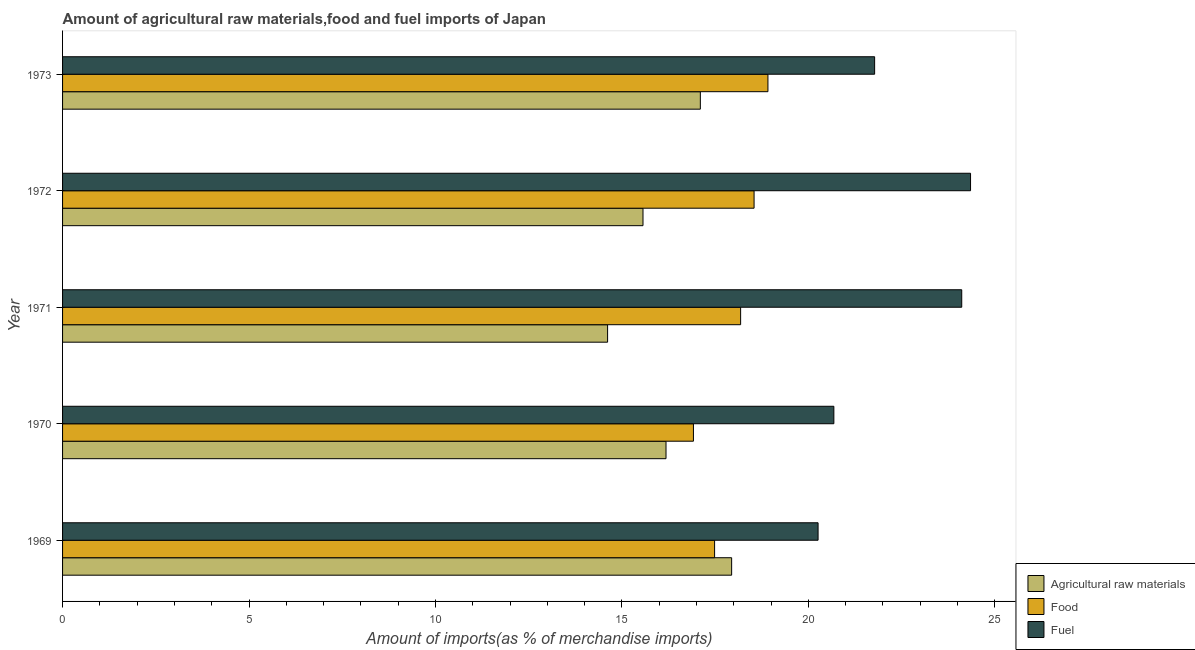How many groups of bars are there?
Make the answer very short. 5. Are the number of bars per tick equal to the number of legend labels?
Your answer should be compact. Yes. How many bars are there on the 5th tick from the top?
Your answer should be compact. 3. What is the label of the 2nd group of bars from the top?
Your answer should be very brief. 1972. What is the percentage of raw materials imports in 1972?
Your answer should be very brief. 15.57. Across all years, what is the maximum percentage of fuel imports?
Your answer should be very brief. 24.35. Across all years, what is the minimum percentage of fuel imports?
Provide a succinct answer. 20.26. In which year was the percentage of raw materials imports maximum?
Give a very brief answer. 1969. In which year was the percentage of raw materials imports minimum?
Make the answer very short. 1971. What is the total percentage of food imports in the graph?
Make the answer very short. 90.05. What is the difference between the percentage of fuel imports in 1969 and that in 1970?
Make the answer very short. -0.42. What is the difference between the percentage of raw materials imports in 1969 and the percentage of fuel imports in 1972?
Provide a short and direct response. -6.41. What is the average percentage of food imports per year?
Your response must be concise. 18.01. In the year 1973, what is the difference between the percentage of food imports and percentage of raw materials imports?
Your answer should be very brief. 1.81. What is the ratio of the percentage of fuel imports in 1971 to that in 1972?
Offer a very short reply. 0.99. Is the percentage of fuel imports in 1969 less than that in 1970?
Provide a succinct answer. Yes. Is the difference between the percentage of food imports in 1971 and 1972 greater than the difference between the percentage of raw materials imports in 1971 and 1972?
Ensure brevity in your answer.  Yes. What is the difference between the highest and the second highest percentage of food imports?
Give a very brief answer. 0.37. What is the difference between the highest and the lowest percentage of fuel imports?
Offer a terse response. 4.09. In how many years, is the percentage of fuel imports greater than the average percentage of fuel imports taken over all years?
Provide a short and direct response. 2. What does the 3rd bar from the top in 1972 represents?
Your response must be concise. Agricultural raw materials. What does the 1st bar from the bottom in 1969 represents?
Offer a very short reply. Agricultural raw materials. How many bars are there?
Your response must be concise. 15. Are the values on the major ticks of X-axis written in scientific E-notation?
Make the answer very short. No. Does the graph contain any zero values?
Keep it short and to the point. No. Does the graph contain grids?
Keep it short and to the point. No. How many legend labels are there?
Provide a short and direct response. 3. How are the legend labels stacked?
Your response must be concise. Vertical. What is the title of the graph?
Ensure brevity in your answer.  Amount of agricultural raw materials,food and fuel imports of Japan. What is the label or title of the X-axis?
Offer a terse response. Amount of imports(as % of merchandise imports). What is the Amount of imports(as % of merchandise imports) in Agricultural raw materials in 1969?
Provide a short and direct response. 17.94. What is the Amount of imports(as % of merchandise imports) of Food in 1969?
Give a very brief answer. 17.49. What is the Amount of imports(as % of merchandise imports) in Fuel in 1969?
Provide a succinct answer. 20.26. What is the Amount of imports(as % of merchandise imports) in Agricultural raw materials in 1970?
Provide a short and direct response. 16.18. What is the Amount of imports(as % of merchandise imports) in Food in 1970?
Provide a short and direct response. 16.92. What is the Amount of imports(as % of merchandise imports) of Fuel in 1970?
Your answer should be very brief. 20.68. What is the Amount of imports(as % of merchandise imports) in Agricultural raw materials in 1971?
Your answer should be very brief. 14.62. What is the Amount of imports(as % of merchandise imports) in Food in 1971?
Make the answer very short. 18.18. What is the Amount of imports(as % of merchandise imports) in Fuel in 1971?
Your answer should be very brief. 24.11. What is the Amount of imports(as % of merchandise imports) of Agricultural raw materials in 1972?
Provide a succinct answer. 15.57. What is the Amount of imports(as % of merchandise imports) in Food in 1972?
Keep it short and to the point. 18.54. What is the Amount of imports(as % of merchandise imports) of Fuel in 1972?
Provide a succinct answer. 24.35. What is the Amount of imports(as % of merchandise imports) of Agricultural raw materials in 1973?
Your answer should be compact. 17.1. What is the Amount of imports(as % of merchandise imports) of Food in 1973?
Provide a short and direct response. 18.92. What is the Amount of imports(as % of merchandise imports) of Fuel in 1973?
Make the answer very short. 21.78. Across all years, what is the maximum Amount of imports(as % of merchandise imports) in Agricultural raw materials?
Your response must be concise. 17.94. Across all years, what is the maximum Amount of imports(as % of merchandise imports) in Food?
Your response must be concise. 18.92. Across all years, what is the maximum Amount of imports(as % of merchandise imports) in Fuel?
Your answer should be very brief. 24.35. Across all years, what is the minimum Amount of imports(as % of merchandise imports) of Agricultural raw materials?
Offer a terse response. 14.62. Across all years, what is the minimum Amount of imports(as % of merchandise imports) of Food?
Keep it short and to the point. 16.92. Across all years, what is the minimum Amount of imports(as % of merchandise imports) in Fuel?
Provide a short and direct response. 20.26. What is the total Amount of imports(as % of merchandise imports) in Agricultural raw materials in the graph?
Your answer should be very brief. 81.41. What is the total Amount of imports(as % of merchandise imports) of Food in the graph?
Provide a short and direct response. 90.05. What is the total Amount of imports(as % of merchandise imports) of Fuel in the graph?
Ensure brevity in your answer.  111.19. What is the difference between the Amount of imports(as % of merchandise imports) of Agricultural raw materials in 1969 and that in 1970?
Provide a short and direct response. 1.76. What is the difference between the Amount of imports(as % of merchandise imports) of Food in 1969 and that in 1970?
Provide a short and direct response. 0.57. What is the difference between the Amount of imports(as % of merchandise imports) in Fuel in 1969 and that in 1970?
Provide a succinct answer. -0.42. What is the difference between the Amount of imports(as % of merchandise imports) in Agricultural raw materials in 1969 and that in 1971?
Your answer should be compact. 3.33. What is the difference between the Amount of imports(as % of merchandise imports) of Food in 1969 and that in 1971?
Provide a succinct answer. -0.7. What is the difference between the Amount of imports(as % of merchandise imports) in Fuel in 1969 and that in 1971?
Provide a succinct answer. -3.85. What is the difference between the Amount of imports(as % of merchandise imports) of Agricultural raw materials in 1969 and that in 1972?
Make the answer very short. 2.38. What is the difference between the Amount of imports(as % of merchandise imports) of Food in 1969 and that in 1972?
Ensure brevity in your answer.  -1.06. What is the difference between the Amount of imports(as % of merchandise imports) in Fuel in 1969 and that in 1972?
Provide a succinct answer. -4.09. What is the difference between the Amount of imports(as % of merchandise imports) of Agricultural raw materials in 1969 and that in 1973?
Provide a succinct answer. 0.84. What is the difference between the Amount of imports(as % of merchandise imports) in Food in 1969 and that in 1973?
Make the answer very short. -1.43. What is the difference between the Amount of imports(as % of merchandise imports) of Fuel in 1969 and that in 1973?
Provide a short and direct response. -1.52. What is the difference between the Amount of imports(as % of merchandise imports) in Agricultural raw materials in 1970 and that in 1971?
Your answer should be very brief. 1.57. What is the difference between the Amount of imports(as % of merchandise imports) of Food in 1970 and that in 1971?
Make the answer very short. -1.27. What is the difference between the Amount of imports(as % of merchandise imports) in Fuel in 1970 and that in 1971?
Your answer should be compact. -3.43. What is the difference between the Amount of imports(as % of merchandise imports) in Agricultural raw materials in 1970 and that in 1972?
Offer a terse response. 0.62. What is the difference between the Amount of imports(as % of merchandise imports) of Food in 1970 and that in 1972?
Give a very brief answer. -1.63. What is the difference between the Amount of imports(as % of merchandise imports) in Fuel in 1970 and that in 1972?
Provide a succinct answer. -3.67. What is the difference between the Amount of imports(as % of merchandise imports) in Agricultural raw materials in 1970 and that in 1973?
Your response must be concise. -0.92. What is the difference between the Amount of imports(as % of merchandise imports) of Food in 1970 and that in 1973?
Your answer should be compact. -2. What is the difference between the Amount of imports(as % of merchandise imports) of Fuel in 1970 and that in 1973?
Give a very brief answer. -1.09. What is the difference between the Amount of imports(as % of merchandise imports) in Agricultural raw materials in 1971 and that in 1972?
Keep it short and to the point. -0.95. What is the difference between the Amount of imports(as % of merchandise imports) of Food in 1971 and that in 1972?
Your response must be concise. -0.36. What is the difference between the Amount of imports(as % of merchandise imports) of Fuel in 1971 and that in 1972?
Give a very brief answer. -0.24. What is the difference between the Amount of imports(as % of merchandise imports) in Agricultural raw materials in 1971 and that in 1973?
Offer a very short reply. -2.49. What is the difference between the Amount of imports(as % of merchandise imports) in Food in 1971 and that in 1973?
Make the answer very short. -0.73. What is the difference between the Amount of imports(as % of merchandise imports) in Fuel in 1971 and that in 1973?
Offer a terse response. 2.34. What is the difference between the Amount of imports(as % of merchandise imports) of Agricultural raw materials in 1972 and that in 1973?
Provide a succinct answer. -1.54. What is the difference between the Amount of imports(as % of merchandise imports) in Food in 1972 and that in 1973?
Ensure brevity in your answer.  -0.37. What is the difference between the Amount of imports(as % of merchandise imports) of Fuel in 1972 and that in 1973?
Provide a short and direct response. 2.57. What is the difference between the Amount of imports(as % of merchandise imports) of Agricultural raw materials in 1969 and the Amount of imports(as % of merchandise imports) of Food in 1970?
Provide a succinct answer. 1.02. What is the difference between the Amount of imports(as % of merchandise imports) of Agricultural raw materials in 1969 and the Amount of imports(as % of merchandise imports) of Fuel in 1970?
Ensure brevity in your answer.  -2.74. What is the difference between the Amount of imports(as % of merchandise imports) of Food in 1969 and the Amount of imports(as % of merchandise imports) of Fuel in 1970?
Your answer should be very brief. -3.2. What is the difference between the Amount of imports(as % of merchandise imports) in Agricultural raw materials in 1969 and the Amount of imports(as % of merchandise imports) in Food in 1971?
Provide a succinct answer. -0.24. What is the difference between the Amount of imports(as % of merchandise imports) in Agricultural raw materials in 1969 and the Amount of imports(as % of merchandise imports) in Fuel in 1971?
Offer a very short reply. -6.17. What is the difference between the Amount of imports(as % of merchandise imports) in Food in 1969 and the Amount of imports(as % of merchandise imports) in Fuel in 1971?
Provide a succinct answer. -6.63. What is the difference between the Amount of imports(as % of merchandise imports) of Agricultural raw materials in 1969 and the Amount of imports(as % of merchandise imports) of Food in 1972?
Keep it short and to the point. -0.6. What is the difference between the Amount of imports(as % of merchandise imports) in Agricultural raw materials in 1969 and the Amount of imports(as % of merchandise imports) in Fuel in 1972?
Your answer should be very brief. -6.41. What is the difference between the Amount of imports(as % of merchandise imports) of Food in 1969 and the Amount of imports(as % of merchandise imports) of Fuel in 1972?
Keep it short and to the point. -6.86. What is the difference between the Amount of imports(as % of merchandise imports) of Agricultural raw materials in 1969 and the Amount of imports(as % of merchandise imports) of Food in 1973?
Offer a terse response. -0.97. What is the difference between the Amount of imports(as % of merchandise imports) of Agricultural raw materials in 1969 and the Amount of imports(as % of merchandise imports) of Fuel in 1973?
Ensure brevity in your answer.  -3.83. What is the difference between the Amount of imports(as % of merchandise imports) in Food in 1969 and the Amount of imports(as % of merchandise imports) in Fuel in 1973?
Provide a short and direct response. -4.29. What is the difference between the Amount of imports(as % of merchandise imports) of Agricultural raw materials in 1970 and the Amount of imports(as % of merchandise imports) of Food in 1971?
Your response must be concise. -2. What is the difference between the Amount of imports(as % of merchandise imports) in Agricultural raw materials in 1970 and the Amount of imports(as % of merchandise imports) in Fuel in 1971?
Your response must be concise. -7.93. What is the difference between the Amount of imports(as % of merchandise imports) of Food in 1970 and the Amount of imports(as % of merchandise imports) of Fuel in 1971?
Make the answer very short. -7.2. What is the difference between the Amount of imports(as % of merchandise imports) in Agricultural raw materials in 1970 and the Amount of imports(as % of merchandise imports) in Food in 1972?
Ensure brevity in your answer.  -2.36. What is the difference between the Amount of imports(as % of merchandise imports) in Agricultural raw materials in 1970 and the Amount of imports(as % of merchandise imports) in Fuel in 1972?
Ensure brevity in your answer.  -8.17. What is the difference between the Amount of imports(as % of merchandise imports) in Food in 1970 and the Amount of imports(as % of merchandise imports) in Fuel in 1972?
Your response must be concise. -7.43. What is the difference between the Amount of imports(as % of merchandise imports) of Agricultural raw materials in 1970 and the Amount of imports(as % of merchandise imports) of Food in 1973?
Offer a terse response. -2.73. What is the difference between the Amount of imports(as % of merchandise imports) of Agricultural raw materials in 1970 and the Amount of imports(as % of merchandise imports) of Fuel in 1973?
Give a very brief answer. -5.59. What is the difference between the Amount of imports(as % of merchandise imports) of Food in 1970 and the Amount of imports(as % of merchandise imports) of Fuel in 1973?
Your answer should be compact. -4.86. What is the difference between the Amount of imports(as % of merchandise imports) of Agricultural raw materials in 1971 and the Amount of imports(as % of merchandise imports) of Food in 1972?
Ensure brevity in your answer.  -3.93. What is the difference between the Amount of imports(as % of merchandise imports) in Agricultural raw materials in 1971 and the Amount of imports(as % of merchandise imports) in Fuel in 1972?
Your answer should be compact. -9.73. What is the difference between the Amount of imports(as % of merchandise imports) of Food in 1971 and the Amount of imports(as % of merchandise imports) of Fuel in 1972?
Your answer should be very brief. -6.17. What is the difference between the Amount of imports(as % of merchandise imports) in Agricultural raw materials in 1971 and the Amount of imports(as % of merchandise imports) in Food in 1973?
Offer a terse response. -4.3. What is the difference between the Amount of imports(as % of merchandise imports) in Agricultural raw materials in 1971 and the Amount of imports(as % of merchandise imports) in Fuel in 1973?
Ensure brevity in your answer.  -7.16. What is the difference between the Amount of imports(as % of merchandise imports) in Food in 1971 and the Amount of imports(as % of merchandise imports) in Fuel in 1973?
Offer a terse response. -3.59. What is the difference between the Amount of imports(as % of merchandise imports) in Agricultural raw materials in 1972 and the Amount of imports(as % of merchandise imports) in Food in 1973?
Give a very brief answer. -3.35. What is the difference between the Amount of imports(as % of merchandise imports) in Agricultural raw materials in 1972 and the Amount of imports(as % of merchandise imports) in Fuel in 1973?
Make the answer very short. -6.21. What is the difference between the Amount of imports(as % of merchandise imports) of Food in 1972 and the Amount of imports(as % of merchandise imports) of Fuel in 1973?
Offer a terse response. -3.23. What is the average Amount of imports(as % of merchandise imports) in Agricultural raw materials per year?
Give a very brief answer. 16.28. What is the average Amount of imports(as % of merchandise imports) in Food per year?
Provide a short and direct response. 18.01. What is the average Amount of imports(as % of merchandise imports) in Fuel per year?
Keep it short and to the point. 22.24. In the year 1969, what is the difference between the Amount of imports(as % of merchandise imports) of Agricultural raw materials and Amount of imports(as % of merchandise imports) of Food?
Ensure brevity in your answer.  0.46. In the year 1969, what is the difference between the Amount of imports(as % of merchandise imports) in Agricultural raw materials and Amount of imports(as % of merchandise imports) in Fuel?
Provide a short and direct response. -2.32. In the year 1969, what is the difference between the Amount of imports(as % of merchandise imports) of Food and Amount of imports(as % of merchandise imports) of Fuel?
Offer a terse response. -2.78. In the year 1970, what is the difference between the Amount of imports(as % of merchandise imports) in Agricultural raw materials and Amount of imports(as % of merchandise imports) in Food?
Your answer should be very brief. -0.74. In the year 1970, what is the difference between the Amount of imports(as % of merchandise imports) of Agricultural raw materials and Amount of imports(as % of merchandise imports) of Fuel?
Keep it short and to the point. -4.5. In the year 1970, what is the difference between the Amount of imports(as % of merchandise imports) in Food and Amount of imports(as % of merchandise imports) in Fuel?
Offer a terse response. -3.77. In the year 1971, what is the difference between the Amount of imports(as % of merchandise imports) of Agricultural raw materials and Amount of imports(as % of merchandise imports) of Food?
Your response must be concise. -3.57. In the year 1971, what is the difference between the Amount of imports(as % of merchandise imports) in Agricultural raw materials and Amount of imports(as % of merchandise imports) in Fuel?
Ensure brevity in your answer.  -9.5. In the year 1971, what is the difference between the Amount of imports(as % of merchandise imports) of Food and Amount of imports(as % of merchandise imports) of Fuel?
Provide a succinct answer. -5.93. In the year 1972, what is the difference between the Amount of imports(as % of merchandise imports) in Agricultural raw materials and Amount of imports(as % of merchandise imports) in Food?
Your answer should be compact. -2.98. In the year 1972, what is the difference between the Amount of imports(as % of merchandise imports) in Agricultural raw materials and Amount of imports(as % of merchandise imports) in Fuel?
Offer a terse response. -8.78. In the year 1972, what is the difference between the Amount of imports(as % of merchandise imports) in Food and Amount of imports(as % of merchandise imports) in Fuel?
Your answer should be compact. -5.81. In the year 1973, what is the difference between the Amount of imports(as % of merchandise imports) in Agricultural raw materials and Amount of imports(as % of merchandise imports) in Food?
Ensure brevity in your answer.  -1.81. In the year 1973, what is the difference between the Amount of imports(as % of merchandise imports) in Agricultural raw materials and Amount of imports(as % of merchandise imports) in Fuel?
Your answer should be very brief. -4.67. In the year 1973, what is the difference between the Amount of imports(as % of merchandise imports) of Food and Amount of imports(as % of merchandise imports) of Fuel?
Offer a very short reply. -2.86. What is the ratio of the Amount of imports(as % of merchandise imports) of Agricultural raw materials in 1969 to that in 1970?
Offer a terse response. 1.11. What is the ratio of the Amount of imports(as % of merchandise imports) of Food in 1969 to that in 1970?
Offer a very short reply. 1.03. What is the ratio of the Amount of imports(as % of merchandise imports) of Fuel in 1969 to that in 1970?
Keep it short and to the point. 0.98. What is the ratio of the Amount of imports(as % of merchandise imports) in Agricultural raw materials in 1969 to that in 1971?
Your response must be concise. 1.23. What is the ratio of the Amount of imports(as % of merchandise imports) in Food in 1969 to that in 1971?
Give a very brief answer. 0.96. What is the ratio of the Amount of imports(as % of merchandise imports) in Fuel in 1969 to that in 1971?
Your answer should be very brief. 0.84. What is the ratio of the Amount of imports(as % of merchandise imports) of Agricultural raw materials in 1969 to that in 1972?
Your response must be concise. 1.15. What is the ratio of the Amount of imports(as % of merchandise imports) of Food in 1969 to that in 1972?
Offer a very short reply. 0.94. What is the ratio of the Amount of imports(as % of merchandise imports) in Fuel in 1969 to that in 1972?
Ensure brevity in your answer.  0.83. What is the ratio of the Amount of imports(as % of merchandise imports) in Agricultural raw materials in 1969 to that in 1973?
Provide a short and direct response. 1.05. What is the ratio of the Amount of imports(as % of merchandise imports) in Food in 1969 to that in 1973?
Offer a very short reply. 0.92. What is the ratio of the Amount of imports(as % of merchandise imports) in Fuel in 1969 to that in 1973?
Offer a terse response. 0.93. What is the ratio of the Amount of imports(as % of merchandise imports) of Agricultural raw materials in 1970 to that in 1971?
Give a very brief answer. 1.11. What is the ratio of the Amount of imports(as % of merchandise imports) in Food in 1970 to that in 1971?
Your answer should be very brief. 0.93. What is the ratio of the Amount of imports(as % of merchandise imports) in Fuel in 1970 to that in 1971?
Offer a terse response. 0.86. What is the ratio of the Amount of imports(as % of merchandise imports) of Agricultural raw materials in 1970 to that in 1972?
Make the answer very short. 1.04. What is the ratio of the Amount of imports(as % of merchandise imports) in Food in 1970 to that in 1972?
Make the answer very short. 0.91. What is the ratio of the Amount of imports(as % of merchandise imports) in Fuel in 1970 to that in 1972?
Your response must be concise. 0.85. What is the ratio of the Amount of imports(as % of merchandise imports) in Agricultural raw materials in 1970 to that in 1973?
Offer a very short reply. 0.95. What is the ratio of the Amount of imports(as % of merchandise imports) in Food in 1970 to that in 1973?
Your answer should be compact. 0.89. What is the ratio of the Amount of imports(as % of merchandise imports) in Fuel in 1970 to that in 1973?
Keep it short and to the point. 0.95. What is the ratio of the Amount of imports(as % of merchandise imports) in Agricultural raw materials in 1971 to that in 1972?
Your response must be concise. 0.94. What is the ratio of the Amount of imports(as % of merchandise imports) in Food in 1971 to that in 1972?
Give a very brief answer. 0.98. What is the ratio of the Amount of imports(as % of merchandise imports) of Fuel in 1971 to that in 1972?
Give a very brief answer. 0.99. What is the ratio of the Amount of imports(as % of merchandise imports) of Agricultural raw materials in 1971 to that in 1973?
Provide a succinct answer. 0.85. What is the ratio of the Amount of imports(as % of merchandise imports) in Food in 1971 to that in 1973?
Keep it short and to the point. 0.96. What is the ratio of the Amount of imports(as % of merchandise imports) in Fuel in 1971 to that in 1973?
Ensure brevity in your answer.  1.11. What is the ratio of the Amount of imports(as % of merchandise imports) of Agricultural raw materials in 1972 to that in 1973?
Give a very brief answer. 0.91. What is the ratio of the Amount of imports(as % of merchandise imports) of Food in 1972 to that in 1973?
Make the answer very short. 0.98. What is the ratio of the Amount of imports(as % of merchandise imports) in Fuel in 1972 to that in 1973?
Make the answer very short. 1.12. What is the difference between the highest and the second highest Amount of imports(as % of merchandise imports) in Agricultural raw materials?
Your answer should be compact. 0.84. What is the difference between the highest and the second highest Amount of imports(as % of merchandise imports) of Food?
Your answer should be very brief. 0.37. What is the difference between the highest and the second highest Amount of imports(as % of merchandise imports) of Fuel?
Provide a short and direct response. 0.24. What is the difference between the highest and the lowest Amount of imports(as % of merchandise imports) of Agricultural raw materials?
Make the answer very short. 3.33. What is the difference between the highest and the lowest Amount of imports(as % of merchandise imports) of Food?
Your answer should be compact. 2. What is the difference between the highest and the lowest Amount of imports(as % of merchandise imports) in Fuel?
Offer a terse response. 4.09. 